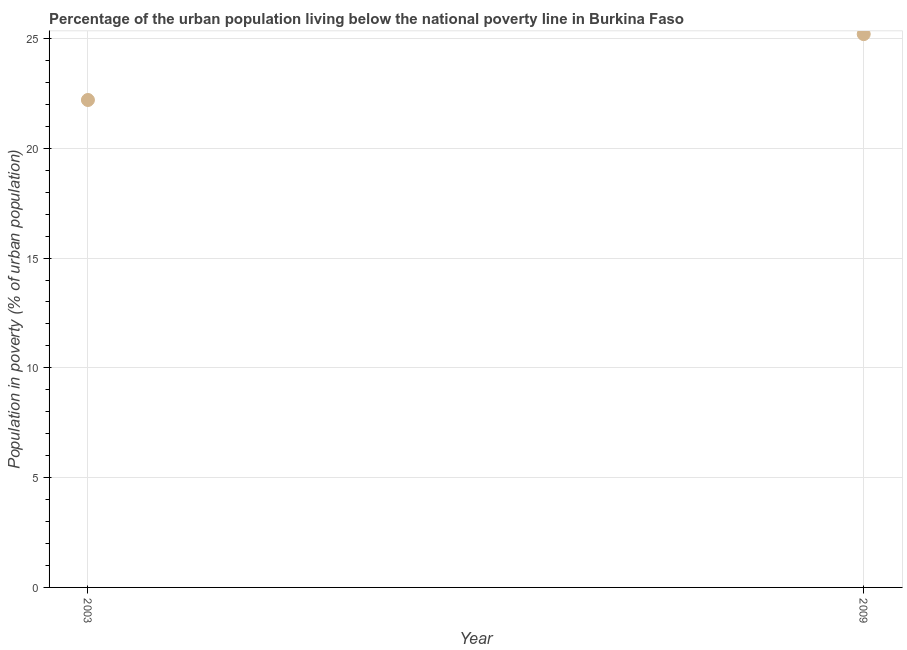What is the percentage of urban population living below poverty line in 2009?
Your answer should be compact. 25.2. Across all years, what is the maximum percentage of urban population living below poverty line?
Provide a short and direct response. 25.2. Across all years, what is the minimum percentage of urban population living below poverty line?
Offer a very short reply. 22.2. What is the sum of the percentage of urban population living below poverty line?
Ensure brevity in your answer.  47.4. What is the average percentage of urban population living below poverty line per year?
Your answer should be very brief. 23.7. What is the median percentage of urban population living below poverty line?
Provide a succinct answer. 23.7. In how many years, is the percentage of urban population living below poverty line greater than 13 %?
Provide a succinct answer. 2. What is the ratio of the percentage of urban population living below poverty line in 2003 to that in 2009?
Your answer should be compact. 0.88. In how many years, is the percentage of urban population living below poverty line greater than the average percentage of urban population living below poverty line taken over all years?
Give a very brief answer. 1. Does the percentage of urban population living below poverty line monotonically increase over the years?
Your response must be concise. Yes. How many dotlines are there?
Make the answer very short. 1. How many years are there in the graph?
Make the answer very short. 2. Are the values on the major ticks of Y-axis written in scientific E-notation?
Make the answer very short. No. Does the graph contain any zero values?
Your answer should be very brief. No. What is the title of the graph?
Provide a succinct answer. Percentage of the urban population living below the national poverty line in Burkina Faso. What is the label or title of the Y-axis?
Your response must be concise. Population in poverty (% of urban population). What is the Population in poverty (% of urban population) in 2009?
Make the answer very short. 25.2. What is the difference between the Population in poverty (% of urban population) in 2003 and 2009?
Your answer should be very brief. -3. What is the ratio of the Population in poverty (% of urban population) in 2003 to that in 2009?
Provide a short and direct response. 0.88. 